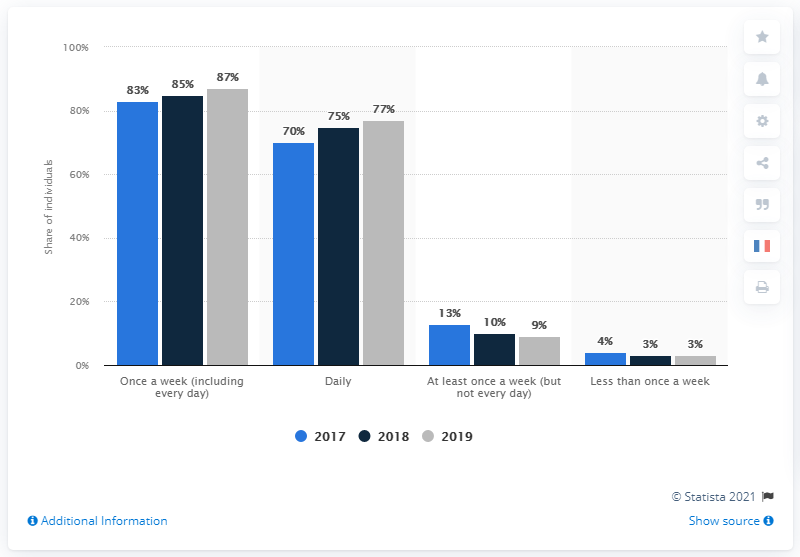Give some essential details in this illustration. The average value of data from 2017 is 42.5. The highest value in the dark blue bar is 85. 